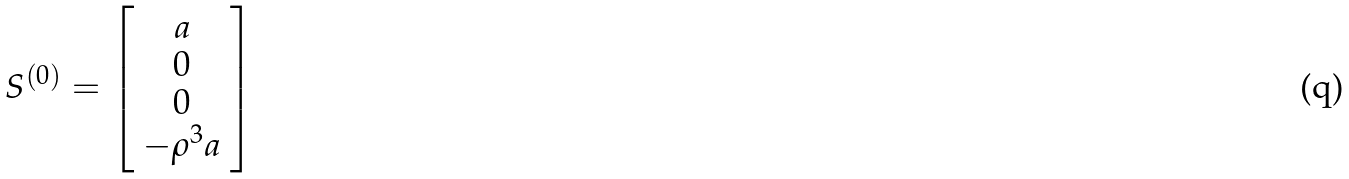Convert formula to latex. <formula><loc_0><loc_0><loc_500><loc_500>S ^ { ( 0 ) } = \left [ \begin{array} { c } a \\ 0 \\ 0 \\ - \rho ^ { 3 } a \end{array} \right ]</formula> 